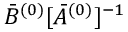Convert formula to latex. <formula><loc_0><loc_0><loc_500><loc_500>\bar { B } ^ { ( 0 ) } [ \bar { A } ^ { ( 0 ) } ] ^ { - 1 }</formula> 